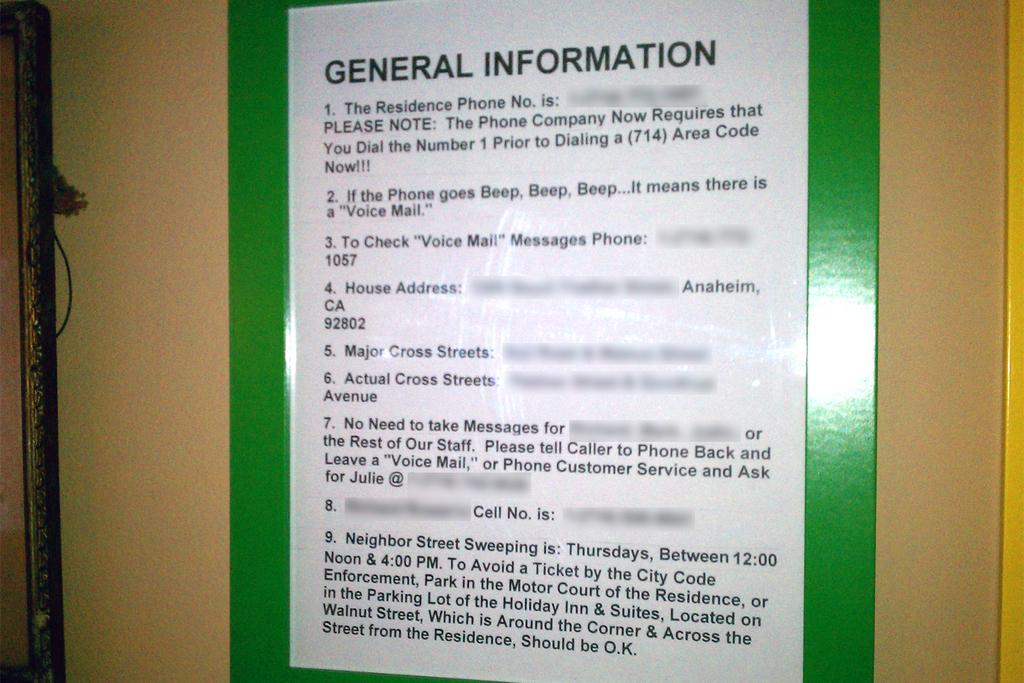<image>
Relay a brief, clear account of the picture shown. A General Information sign is hung on a wall and has instructions to check voicemail and shows the house address as well as other information. 